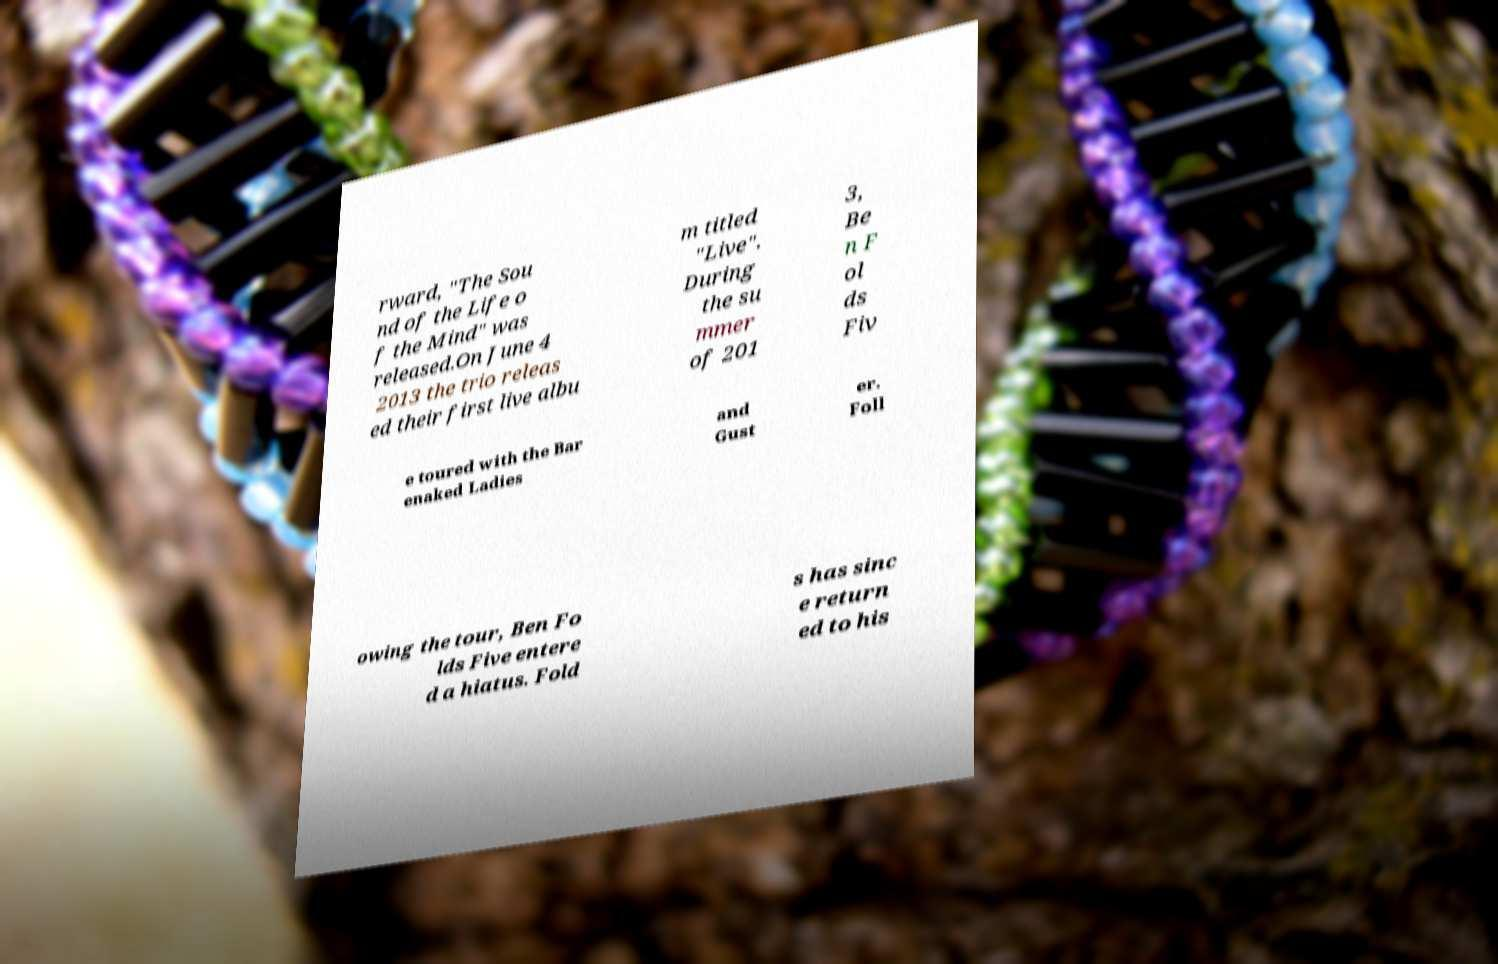What messages or text are displayed in this image? I need them in a readable, typed format. rward, "The Sou nd of the Life o f the Mind" was released.On June 4 2013 the trio releas ed their first live albu m titled "Live". During the su mmer of 201 3, Be n F ol ds Fiv e toured with the Bar enaked Ladies and Gust er. Foll owing the tour, Ben Fo lds Five entere d a hiatus. Fold s has sinc e return ed to his 